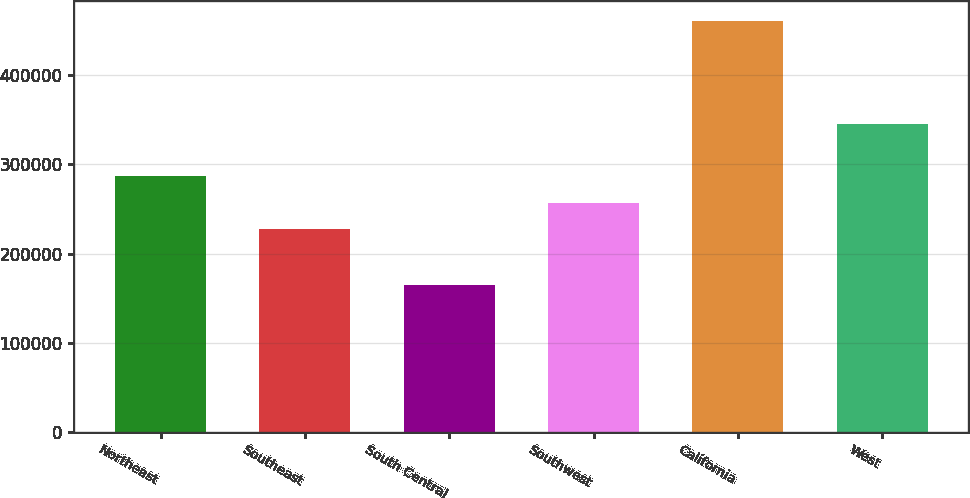Convert chart. <chart><loc_0><loc_0><loc_500><loc_500><bar_chart><fcel>Northeast<fcel>Southeast<fcel>South Central<fcel>Southwest<fcel>California<fcel>West<nl><fcel>286680<fcel>227600<fcel>165200<fcel>257140<fcel>460600<fcel>345300<nl></chart> 